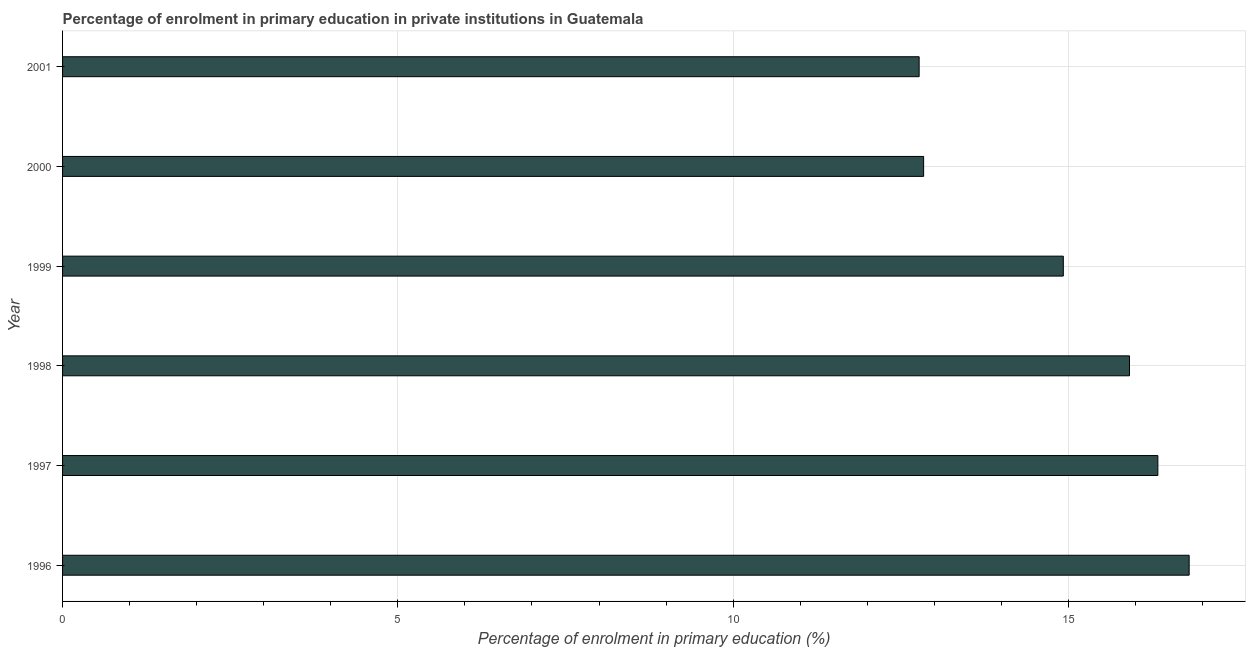Does the graph contain any zero values?
Provide a short and direct response. No. Does the graph contain grids?
Provide a succinct answer. Yes. What is the title of the graph?
Make the answer very short. Percentage of enrolment in primary education in private institutions in Guatemala. What is the label or title of the X-axis?
Make the answer very short. Percentage of enrolment in primary education (%). What is the label or title of the Y-axis?
Provide a short and direct response. Year. What is the enrolment percentage in primary education in 1999?
Provide a succinct answer. 14.92. Across all years, what is the maximum enrolment percentage in primary education?
Your response must be concise. 16.8. Across all years, what is the minimum enrolment percentage in primary education?
Your response must be concise. 12.77. In which year was the enrolment percentage in primary education maximum?
Your response must be concise. 1996. In which year was the enrolment percentage in primary education minimum?
Make the answer very short. 2001. What is the sum of the enrolment percentage in primary education?
Keep it short and to the point. 89.59. What is the difference between the enrolment percentage in primary education in 1999 and 2001?
Your answer should be compact. 2.15. What is the average enrolment percentage in primary education per year?
Offer a very short reply. 14.93. What is the median enrolment percentage in primary education?
Your response must be concise. 15.42. Do a majority of the years between 1998 and 2001 (inclusive) have enrolment percentage in primary education greater than 11 %?
Offer a terse response. Yes. What is the ratio of the enrolment percentage in primary education in 1997 to that in 1999?
Your answer should be very brief. 1.09. Is the difference between the enrolment percentage in primary education in 1996 and 2001 greater than the difference between any two years?
Give a very brief answer. Yes. What is the difference between the highest and the second highest enrolment percentage in primary education?
Give a very brief answer. 0.47. What is the difference between the highest and the lowest enrolment percentage in primary education?
Make the answer very short. 4.03. How many bars are there?
Make the answer very short. 6. Are all the bars in the graph horizontal?
Your response must be concise. Yes. What is the difference between two consecutive major ticks on the X-axis?
Offer a very short reply. 5. Are the values on the major ticks of X-axis written in scientific E-notation?
Your answer should be very brief. No. What is the Percentage of enrolment in primary education (%) in 1996?
Provide a succinct answer. 16.8. What is the Percentage of enrolment in primary education (%) in 1997?
Provide a succinct answer. 16.33. What is the Percentage of enrolment in primary education (%) in 1998?
Offer a terse response. 15.91. What is the Percentage of enrolment in primary education (%) in 1999?
Your answer should be very brief. 14.92. What is the Percentage of enrolment in primary education (%) in 2000?
Make the answer very short. 12.84. What is the Percentage of enrolment in primary education (%) of 2001?
Keep it short and to the point. 12.77. What is the difference between the Percentage of enrolment in primary education (%) in 1996 and 1997?
Your answer should be compact. 0.47. What is the difference between the Percentage of enrolment in primary education (%) in 1996 and 1998?
Offer a terse response. 0.89. What is the difference between the Percentage of enrolment in primary education (%) in 1996 and 1999?
Give a very brief answer. 1.88. What is the difference between the Percentage of enrolment in primary education (%) in 1996 and 2000?
Give a very brief answer. 3.96. What is the difference between the Percentage of enrolment in primary education (%) in 1996 and 2001?
Give a very brief answer. 4.03. What is the difference between the Percentage of enrolment in primary education (%) in 1997 and 1998?
Make the answer very short. 0.42. What is the difference between the Percentage of enrolment in primary education (%) in 1997 and 1999?
Provide a short and direct response. 1.41. What is the difference between the Percentage of enrolment in primary education (%) in 1997 and 2000?
Offer a very short reply. 3.49. What is the difference between the Percentage of enrolment in primary education (%) in 1997 and 2001?
Give a very brief answer. 3.56. What is the difference between the Percentage of enrolment in primary education (%) in 1998 and 1999?
Your answer should be compact. 0.99. What is the difference between the Percentage of enrolment in primary education (%) in 1998 and 2000?
Provide a short and direct response. 3.07. What is the difference between the Percentage of enrolment in primary education (%) in 1998 and 2001?
Keep it short and to the point. 3.14. What is the difference between the Percentage of enrolment in primary education (%) in 1999 and 2000?
Offer a very short reply. 2.08. What is the difference between the Percentage of enrolment in primary education (%) in 1999 and 2001?
Ensure brevity in your answer.  2.15. What is the difference between the Percentage of enrolment in primary education (%) in 2000 and 2001?
Offer a very short reply. 0.07. What is the ratio of the Percentage of enrolment in primary education (%) in 1996 to that in 1997?
Your response must be concise. 1.03. What is the ratio of the Percentage of enrolment in primary education (%) in 1996 to that in 1998?
Keep it short and to the point. 1.06. What is the ratio of the Percentage of enrolment in primary education (%) in 1996 to that in 1999?
Offer a terse response. 1.13. What is the ratio of the Percentage of enrolment in primary education (%) in 1996 to that in 2000?
Offer a very short reply. 1.31. What is the ratio of the Percentage of enrolment in primary education (%) in 1996 to that in 2001?
Ensure brevity in your answer.  1.31. What is the ratio of the Percentage of enrolment in primary education (%) in 1997 to that in 1998?
Your answer should be very brief. 1.03. What is the ratio of the Percentage of enrolment in primary education (%) in 1997 to that in 1999?
Offer a terse response. 1.09. What is the ratio of the Percentage of enrolment in primary education (%) in 1997 to that in 2000?
Your response must be concise. 1.27. What is the ratio of the Percentage of enrolment in primary education (%) in 1997 to that in 2001?
Keep it short and to the point. 1.28. What is the ratio of the Percentage of enrolment in primary education (%) in 1998 to that in 1999?
Ensure brevity in your answer.  1.07. What is the ratio of the Percentage of enrolment in primary education (%) in 1998 to that in 2000?
Your answer should be compact. 1.24. What is the ratio of the Percentage of enrolment in primary education (%) in 1998 to that in 2001?
Your answer should be compact. 1.25. What is the ratio of the Percentage of enrolment in primary education (%) in 1999 to that in 2000?
Offer a very short reply. 1.16. What is the ratio of the Percentage of enrolment in primary education (%) in 1999 to that in 2001?
Ensure brevity in your answer.  1.17. 